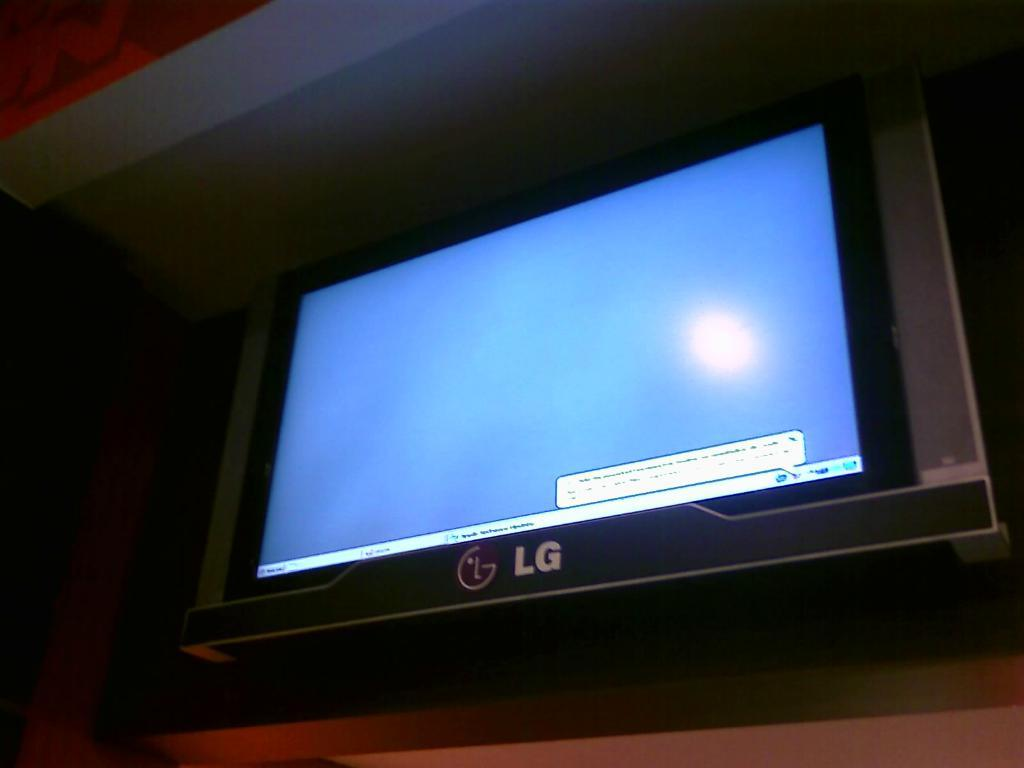<image>
Summarize the visual content of the image. An LG monitor has a small text box in one corner. 